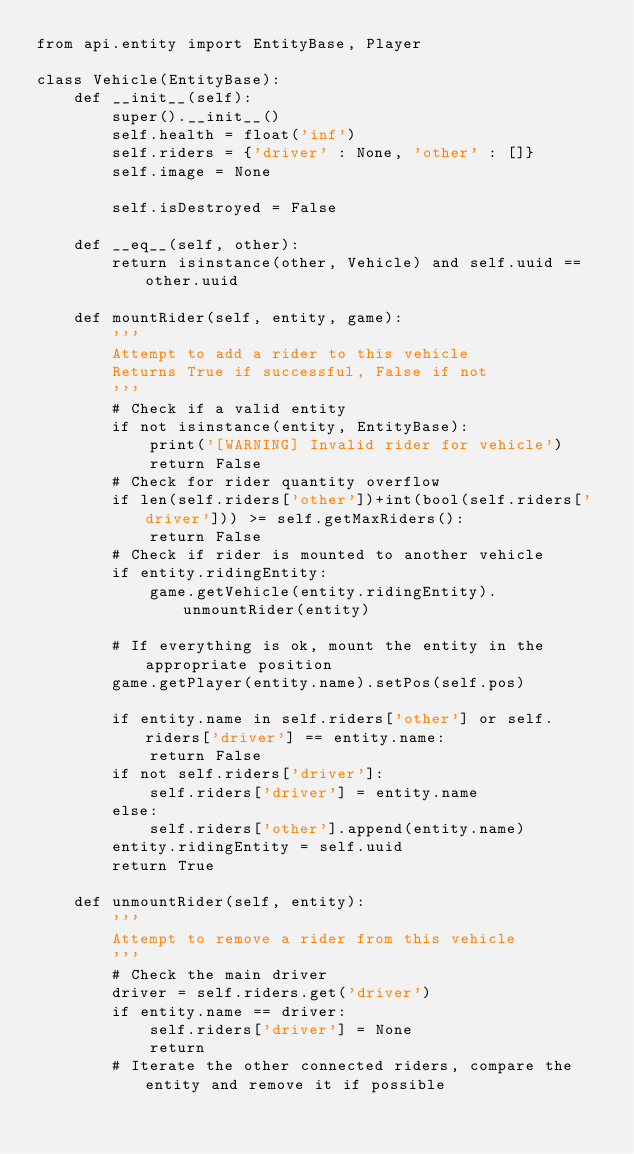Convert code to text. <code><loc_0><loc_0><loc_500><loc_500><_Cython_>from api.entity import EntityBase, Player

class Vehicle(EntityBase):
    def __init__(self):
        super().__init__()
        self.health = float('inf')
        self.riders = {'driver' : None, 'other' : []}
        self.image = None

        self.isDestroyed = False

    def __eq__(self, other):
        return isinstance(other, Vehicle) and self.uuid == other.uuid

    def mountRider(self, entity, game):
        '''
        Attempt to add a rider to this vehicle
        Returns True if successful, False if not
        '''
        # Check if a valid entity
        if not isinstance(entity, EntityBase):
            print('[WARNING] Invalid rider for vehicle')
            return False
        # Check for rider quantity overflow
        if len(self.riders['other'])+int(bool(self.riders['driver'])) >= self.getMaxRiders():
            return False
        # Check if rider is mounted to another vehicle
        if entity.ridingEntity:
            game.getVehicle(entity.ridingEntity).unmountRider(entity)

        # If everything is ok, mount the entity in the appropriate position
        game.getPlayer(entity.name).setPos(self.pos)

        if entity.name in self.riders['other'] or self.riders['driver'] == entity.name:
            return False
        if not self.riders['driver']:
            self.riders['driver'] = entity.name
        else:
            self.riders['other'].append(entity.name)
        entity.ridingEntity = self.uuid
        return True

    def unmountRider(self, entity):
        '''
        Attempt to remove a rider from this vehicle
        '''
        # Check the main driver
        driver = self.riders.get('driver')
        if entity.name == driver:
            self.riders['driver'] = None
            return
        # Iterate the other connected riders, compare the entity and remove it if possible</code> 